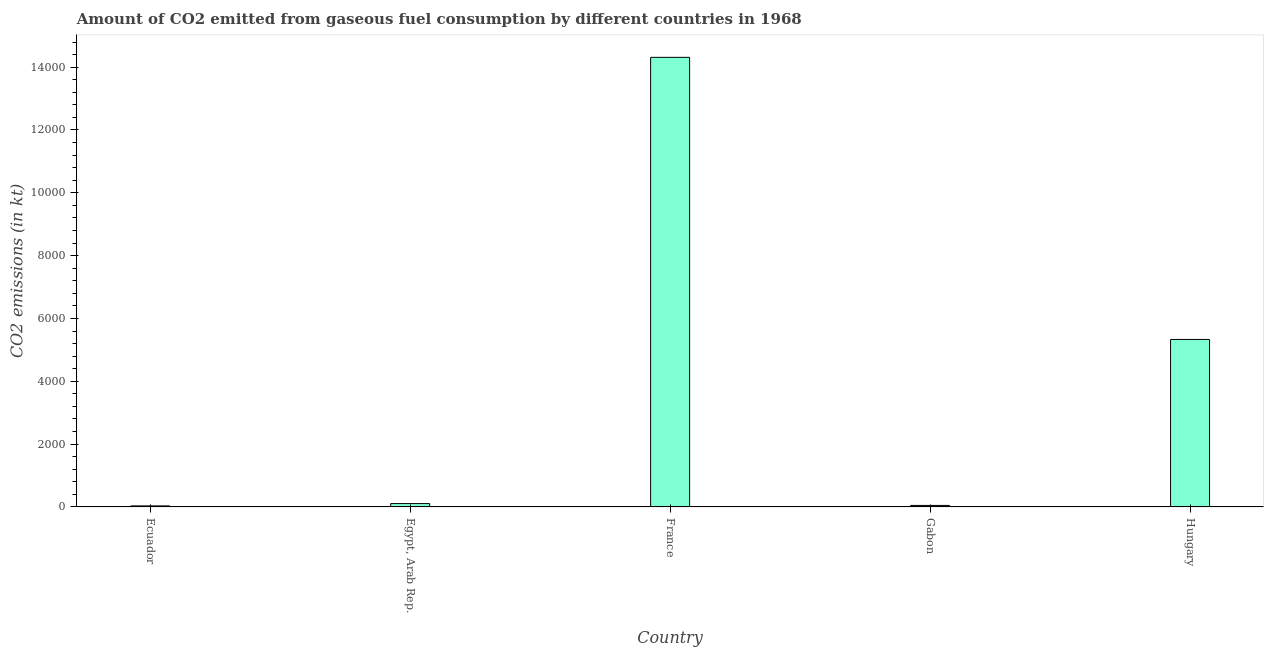Does the graph contain any zero values?
Your answer should be very brief. No. What is the title of the graph?
Provide a short and direct response. Amount of CO2 emitted from gaseous fuel consumption by different countries in 1968. What is the label or title of the X-axis?
Offer a very short reply. Country. What is the label or title of the Y-axis?
Your response must be concise. CO2 emissions (in kt). What is the co2 emissions from gaseous fuel consumption in Gabon?
Keep it short and to the point. 47.67. Across all countries, what is the maximum co2 emissions from gaseous fuel consumption?
Your response must be concise. 1.43e+04. Across all countries, what is the minimum co2 emissions from gaseous fuel consumption?
Provide a short and direct response. 33. In which country was the co2 emissions from gaseous fuel consumption maximum?
Your response must be concise. France. In which country was the co2 emissions from gaseous fuel consumption minimum?
Provide a short and direct response. Ecuador. What is the sum of the co2 emissions from gaseous fuel consumption?
Provide a succinct answer. 1.98e+04. What is the difference between the co2 emissions from gaseous fuel consumption in Gabon and Hungary?
Offer a very short reply. -5284.15. What is the average co2 emissions from gaseous fuel consumption per country?
Offer a very short reply. 3966.23. What is the median co2 emissions from gaseous fuel consumption?
Your response must be concise. 106.34. What is the ratio of the co2 emissions from gaseous fuel consumption in Egypt, Arab Rep. to that in Gabon?
Provide a short and direct response. 2.23. What is the difference between the highest and the second highest co2 emissions from gaseous fuel consumption?
Ensure brevity in your answer.  8980.48. Is the sum of the co2 emissions from gaseous fuel consumption in Gabon and Hungary greater than the maximum co2 emissions from gaseous fuel consumption across all countries?
Your answer should be compact. No. What is the difference between the highest and the lowest co2 emissions from gaseous fuel consumption?
Offer a very short reply. 1.43e+04. In how many countries, is the co2 emissions from gaseous fuel consumption greater than the average co2 emissions from gaseous fuel consumption taken over all countries?
Your response must be concise. 2. How many bars are there?
Keep it short and to the point. 5. Are all the bars in the graph horizontal?
Provide a short and direct response. No. What is the difference between two consecutive major ticks on the Y-axis?
Ensure brevity in your answer.  2000. Are the values on the major ticks of Y-axis written in scientific E-notation?
Offer a terse response. No. What is the CO2 emissions (in kt) of Ecuador?
Your answer should be compact. 33. What is the CO2 emissions (in kt) of Egypt, Arab Rep.?
Offer a terse response. 106.34. What is the CO2 emissions (in kt) of France?
Provide a succinct answer. 1.43e+04. What is the CO2 emissions (in kt) of Gabon?
Your answer should be compact. 47.67. What is the CO2 emissions (in kt) in Hungary?
Your answer should be compact. 5331.82. What is the difference between the CO2 emissions (in kt) in Ecuador and Egypt, Arab Rep.?
Give a very brief answer. -73.34. What is the difference between the CO2 emissions (in kt) in Ecuador and France?
Your response must be concise. -1.43e+04. What is the difference between the CO2 emissions (in kt) in Ecuador and Gabon?
Ensure brevity in your answer.  -14.67. What is the difference between the CO2 emissions (in kt) in Ecuador and Hungary?
Ensure brevity in your answer.  -5298.81. What is the difference between the CO2 emissions (in kt) in Egypt, Arab Rep. and France?
Provide a short and direct response. -1.42e+04. What is the difference between the CO2 emissions (in kt) in Egypt, Arab Rep. and Gabon?
Your response must be concise. 58.67. What is the difference between the CO2 emissions (in kt) in Egypt, Arab Rep. and Hungary?
Provide a succinct answer. -5225.48. What is the difference between the CO2 emissions (in kt) in France and Gabon?
Make the answer very short. 1.43e+04. What is the difference between the CO2 emissions (in kt) in France and Hungary?
Your answer should be compact. 8980.48. What is the difference between the CO2 emissions (in kt) in Gabon and Hungary?
Your answer should be very brief. -5284.15. What is the ratio of the CO2 emissions (in kt) in Ecuador to that in Egypt, Arab Rep.?
Provide a succinct answer. 0.31. What is the ratio of the CO2 emissions (in kt) in Ecuador to that in France?
Keep it short and to the point. 0. What is the ratio of the CO2 emissions (in kt) in Ecuador to that in Gabon?
Keep it short and to the point. 0.69. What is the ratio of the CO2 emissions (in kt) in Ecuador to that in Hungary?
Provide a short and direct response. 0.01. What is the ratio of the CO2 emissions (in kt) in Egypt, Arab Rep. to that in France?
Ensure brevity in your answer.  0.01. What is the ratio of the CO2 emissions (in kt) in Egypt, Arab Rep. to that in Gabon?
Offer a very short reply. 2.23. What is the ratio of the CO2 emissions (in kt) in Egypt, Arab Rep. to that in Hungary?
Give a very brief answer. 0.02. What is the ratio of the CO2 emissions (in kt) in France to that in Gabon?
Provide a short and direct response. 300.23. What is the ratio of the CO2 emissions (in kt) in France to that in Hungary?
Make the answer very short. 2.68. What is the ratio of the CO2 emissions (in kt) in Gabon to that in Hungary?
Offer a very short reply. 0.01. 